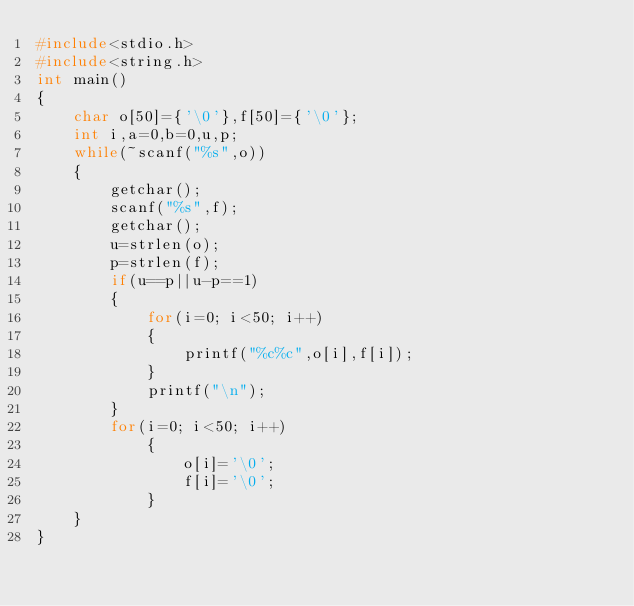Convert code to text. <code><loc_0><loc_0><loc_500><loc_500><_C_>#include<stdio.h>
#include<string.h>
int main()
{
    char o[50]={'\0'},f[50]={'\0'};
    int i,a=0,b=0,u,p;
    while(~scanf("%s",o))
    {
        getchar();
        scanf("%s",f);
        getchar();
        u=strlen(o);
        p=strlen(f);
        if(u==p||u-p==1)
        {
            for(i=0; i<50; i++)
            {
                printf("%c%c",o[i],f[i]);
            }
            printf("\n");
        }
        for(i=0; i<50; i++)
            {
                o[i]='\0';
                f[i]='\0';
            }
    }
}
</code> 